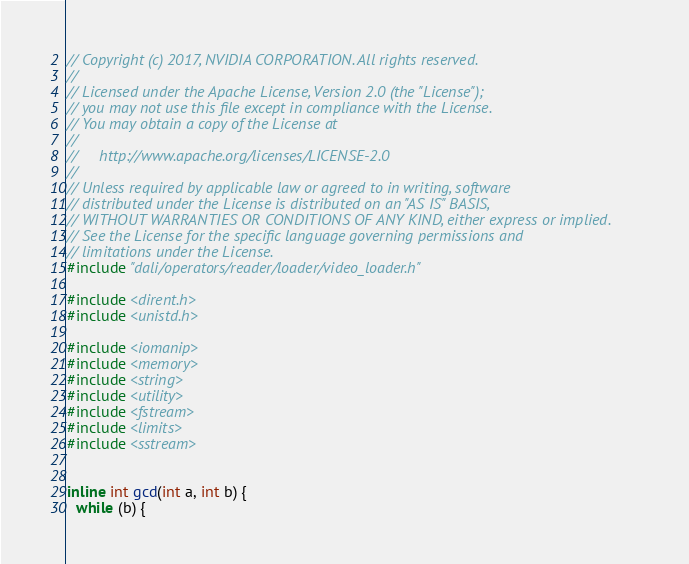<code> <loc_0><loc_0><loc_500><loc_500><_C++_>// Copyright (c) 2017, NVIDIA CORPORATION. All rights reserved.
//
// Licensed under the Apache License, Version 2.0 (the "License");
// you may not use this file except in compliance with the License.
// You may obtain a copy of the License at
//
//     http://www.apache.org/licenses/LICENSE-2.0
//
// Unless required by applicable law or agreed to in writing, software
// distributed under the License is distributed on an "AS IS" BASIS,
// WITHOUT WARRANTIES OR CONDITIONS OF ANY KIND, either express or implied.
// See the License for the specific language governing permissions and
// limitations under the License.
#include "dali/operators/reader/loader/video_loader.h"

#include <dirent.h>
#include <unistd.h>

#include <iomanip>
#include <memory>
#include <string>
#include <utility>
#include <fstream>
#include <limits>
#include <sstream>


inline int gcd(int a, int b) {
  while (b) {</code> 